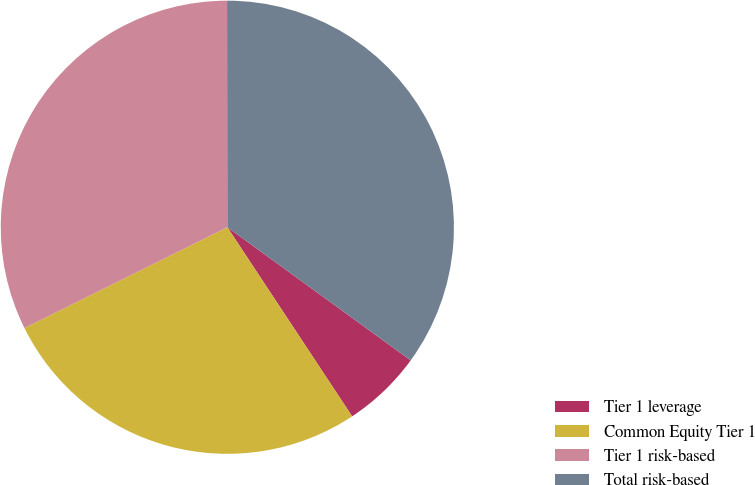Convert chart. <chart><loc_0><loc_0><loc_500><loc_500><pie_chart><fcel>Tier 1 leverage<fcel>Common Equity Tier 1<fcel>Tier 1 risk-based<fcel>Total risk-based<nl><fcel>5.72%<fcel>26.95%<fcel>32.32%<fcel>35.02%<nl></chart> 